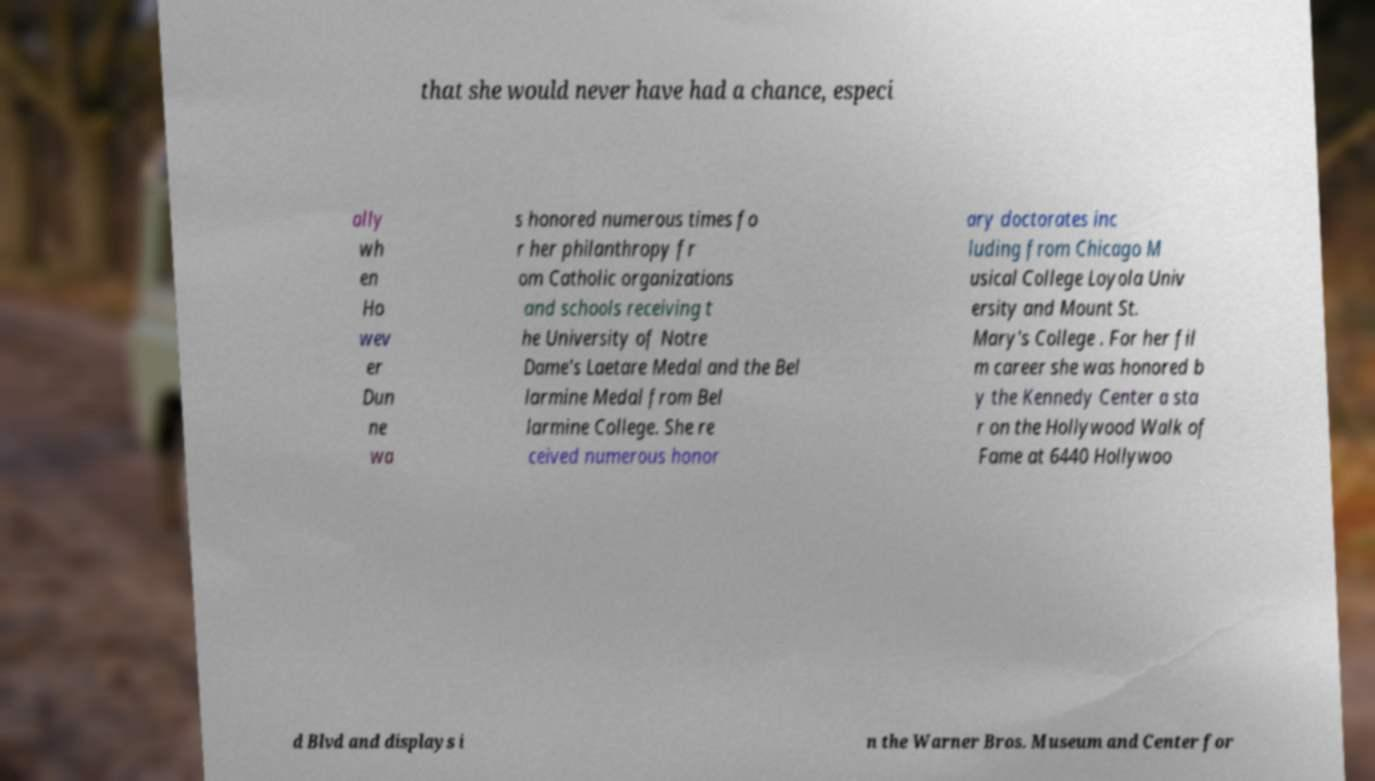What messages or text are displayed in this image? I need them in a readable, typed format. that she would never have had a chance, especi ally wh en Ho wev er Dun ne wa s honored numerous times fo r her philanthropy fr om Catholic organizations and schools receiving t he University of Notre Dame's Laetare Medal and the Bel larmine Medal from Bel larmine College. She re ceived numerous honor ary doctorates inc luding from Chicago M usical College Loyola Univ ersity and Mount St. Mary's College . For her fil m career she was honored b y the Kennedy Center a sta r on the Hollywood Walk of Fame at 6440 Hollywoo d Blvd and displays i n the Warner Bros. Museum and Center for 